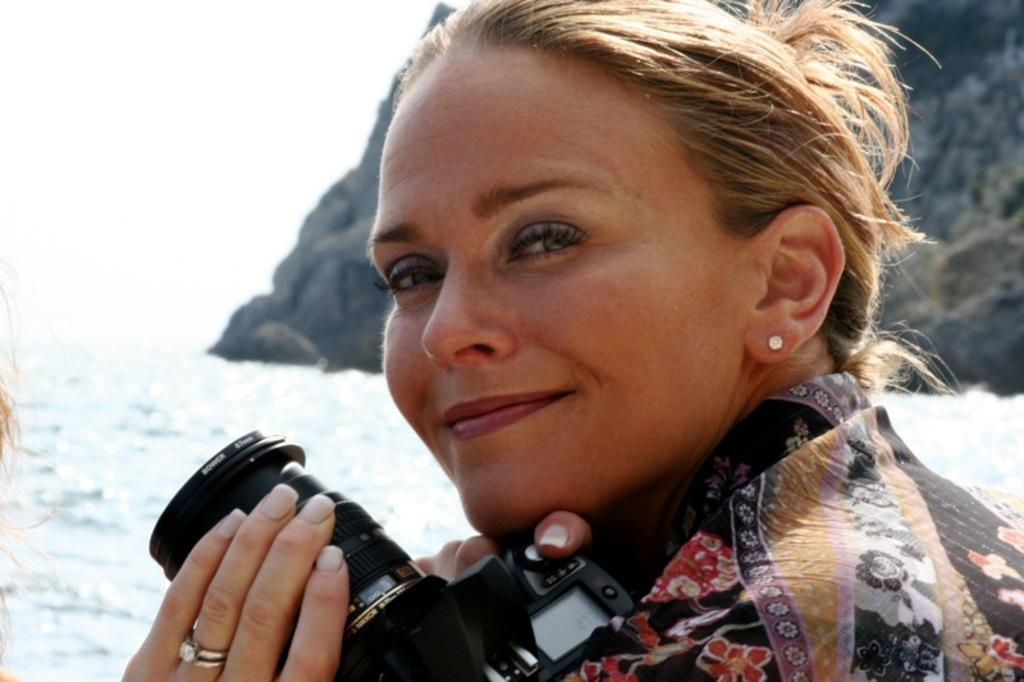What is the main subject of the picture? The main subject of the picture is a woman. What is the woman doing in the image? The woman is standing and smiling in the image. What is the woman holding in her hands? The woman is holding a camera in her hands. Where was the picture taken? The picture was taken in the back of a mountain. What is the weather like in the image? There is snow in the image, indicating a cold or wintry environment. What type of sweater is the woman wearing in the image? There is no sweater visible in the image; the woman is wearing a coat or jacket suitable for the snowy environment. How many fingers is the woman holding up in the image? There is no indication of the woman holding up any fingers in the image; she is simply holding a camera. 